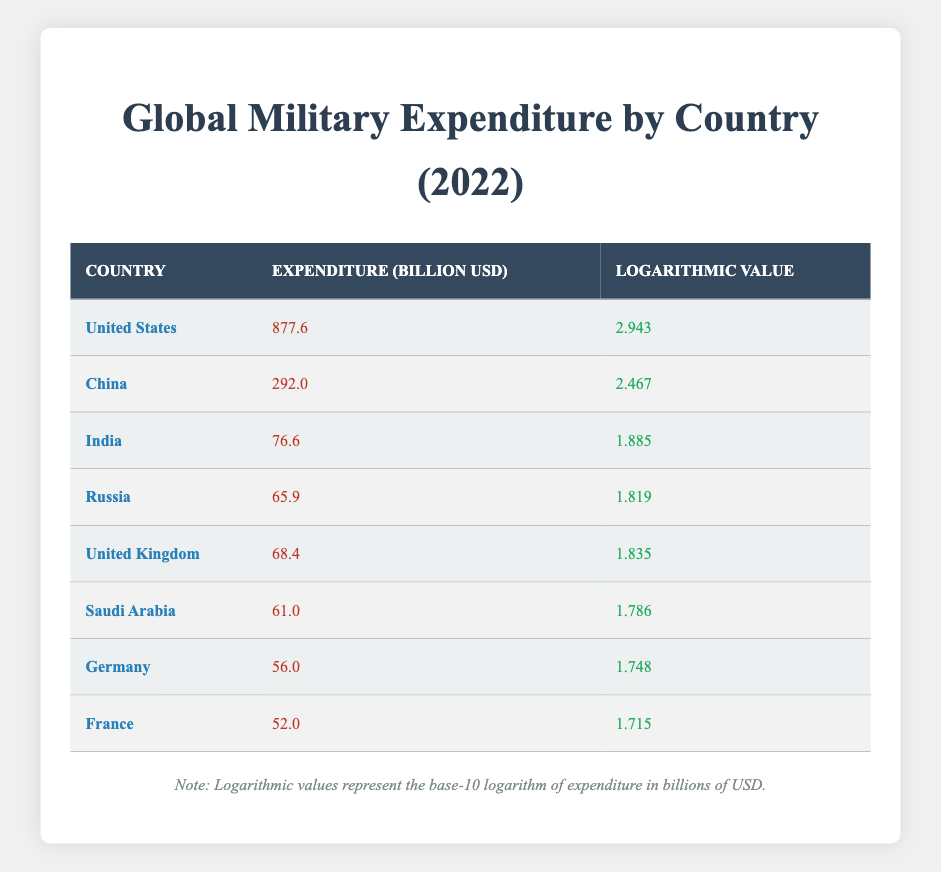What is the military expenditure of the United States in 2022? According to the table, the expenditure listed under "United States" is 877.6 billion USD.
Answer: 877.6 billion USD Which country has the highest military expenditure? The highest value in the "Expenditure" column is associated with the "United States," indicating it has the highest military expenditure.
Answer: United States What is the logarithmic value of China's military expenditure? The table shows that the logarithmic value associated with "China" is 2.467.
Answer: 2.467 Calculate the total military expenditure of the top three countries (United States, China, and India). The expenditures are summed as follows: United States (877.6) + China (292.0) + India (76.6) = 1246.2 billion USD.
Answer: 1246.2 billion USD Is India's military expenditure greater than that of Russia? Comparing the expenditures, India (76.6) is greater than Russia (65.9), confirming that the statement is true.
Answer: Yes What is the average military expenditure of the countries listed in the table? The total expenditure is the sum of all listed countries: 877.6 + 292.0 + 76.6 + 65.9 + 68.4 + 61.0 + 56.0 + 52.0 = 1510.5 billion USD. There are 8 countries, so the average is 1510.5/8 = 188.81 billion USD.
Answer: 188.81 billion USD Which country has a logarithmic value closest to 1.8? The logarithmic values of Russia (1.819) and Saudi Arabia (1.786) both fall close to 1.8, with Russia being slightly higher. Since both are close to that value, either could be mentioned, but Russia is closer.
Answer: Russia Is the military expenditure of Germany less than the global average? First, calculate the average military expenditure (1,510.5 / 8 = 188.81). Germany's expenditure (56.0) is less than this average, confirming the statement.
Answer: Yes 